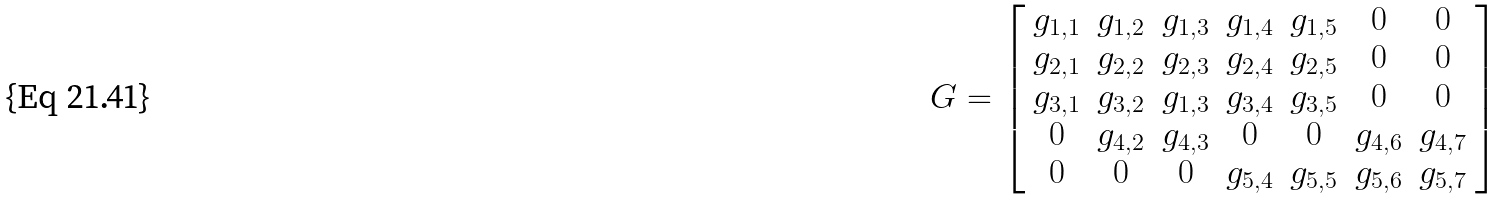<formula> <loc_0><loc_0><loc_500><loc_500>\ G = \left [ \begin{array} { c c c c c c c } g _ { 1 , 1 } & g _ { 1 , 2 } & g _ { 1 , 3 } & g _ { 1 , 4 } & g _ { 1 , 5 } & 0 & 0 \\ g _ { 2 , 1 } & g _ { 2 , 2 } & g _ { 2 , 3 } & g _ { 2 , 4 } & g _ { 2 , 5 } & 0 & 0 \\ g _ { 3 , 1 } & g _ { 3 , 2 } & g _ { 1 , 3 } & g _ { 3 , 4 } & g _ { 3 , 5 } & 0 & 0 \\ 0 & g _ { 4 , 2 } & g _ { 4 , 3 } & 0 & 0 & g _ { 4 , 6 } & g _ { 4 , 7 } \\ 0 & 0 & 0 & g _ { 5 , 4 } & g _ { 5 , 5 } & g _ { 5 , 6 } & g _ { 5 , 7 } \end{array} \right ]</formula> 